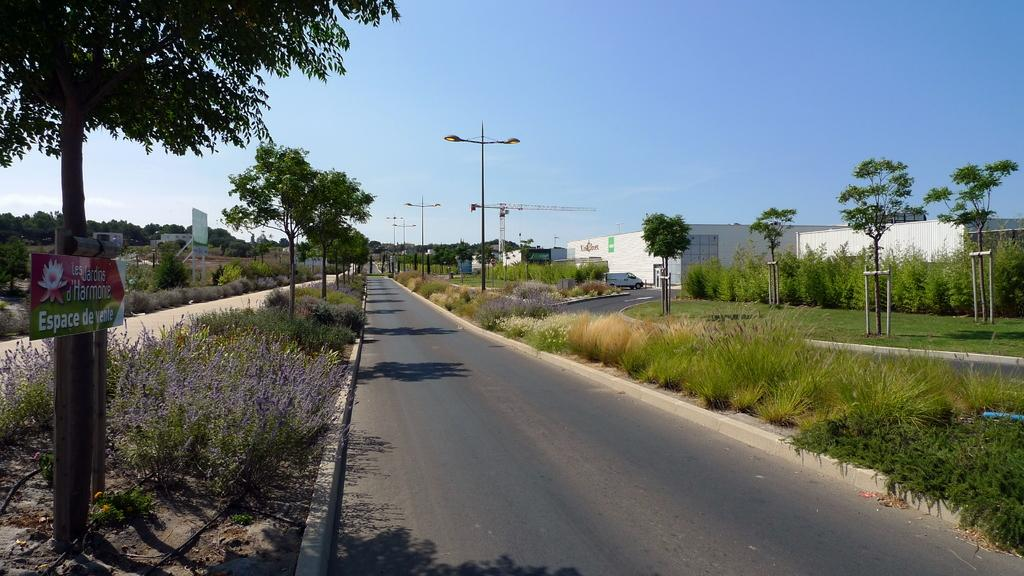What type of vegetation can be seen in the image? There are trees in the image. What is the color of the trees? The trees are green. What is the color of the light pole in the image? The color of the light pole is not mentioned in the facts, so we cannot definitively answer that question. What type of structures are visible in the image? There are buildings in the image. What is the color of the buildings? The buildings are white. What is the color of the sky in the image? A: The sky is blue. Can you tell me how many monkeys are sitting on the buildings in the image? There are no monkeys present in the image; it features trees, a light pole, buildings, and a blue sky. 